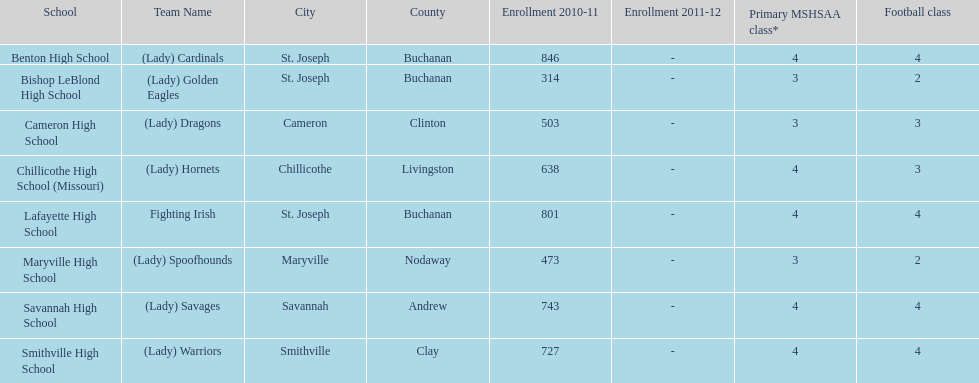Benton high school and bishop leblond high school are both located in what town? St. Joseph. 